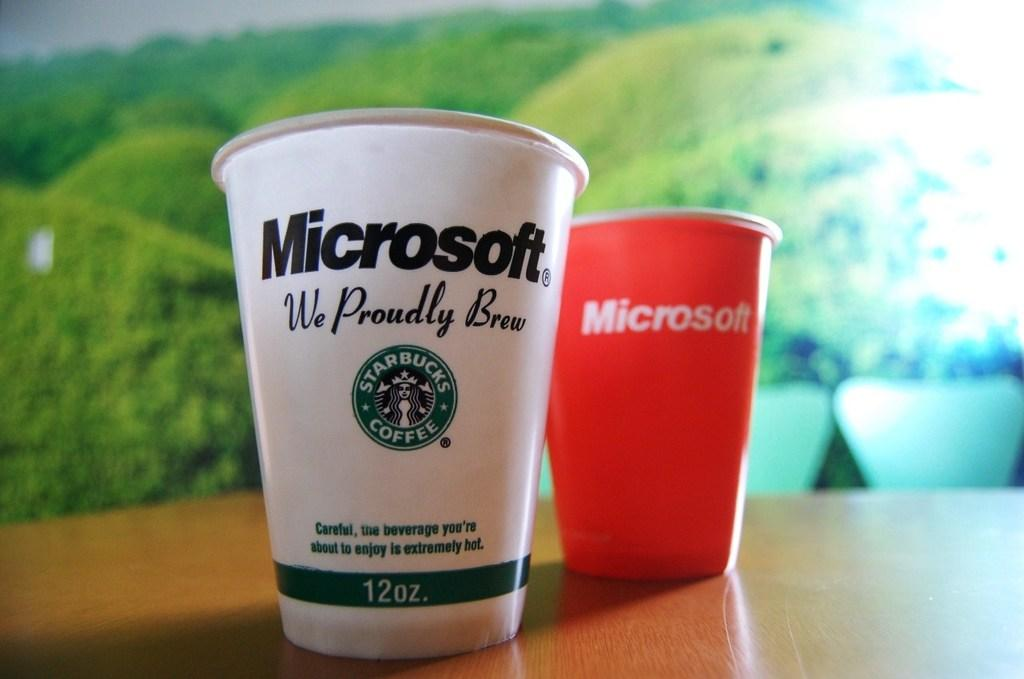How many cups can be seen in the image? There are two cups present in the image. Where are the cups located in the image? The cups are on a surface at the bottom of the image. What can be seen in the background of the image? There is a photo of plants in the background of the image. What type of toy can be seen in the image? There is no toy present in the image. How many buttons are visible on the cups in the image? The cups in the image do not have any visible buttons. 